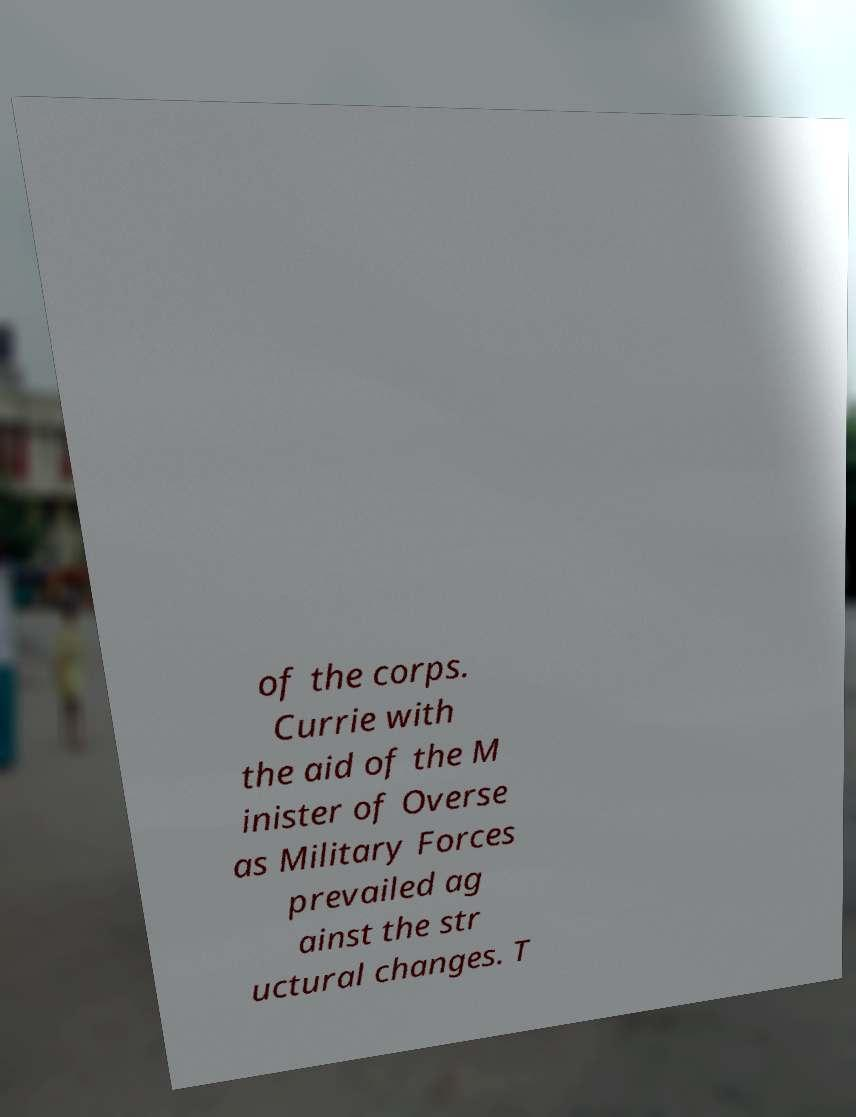Could you assist in decoding the text presented in this image and type it out clearly? of the corps. Currie with the aid of the M inister of Overse as Military Forces prevailed ag ainst the str uctural changes. T 